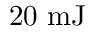Convert formula to latex. <formula><loc_0><loc_0><loc_500><loc_500>2 0 \ m J</formula> 